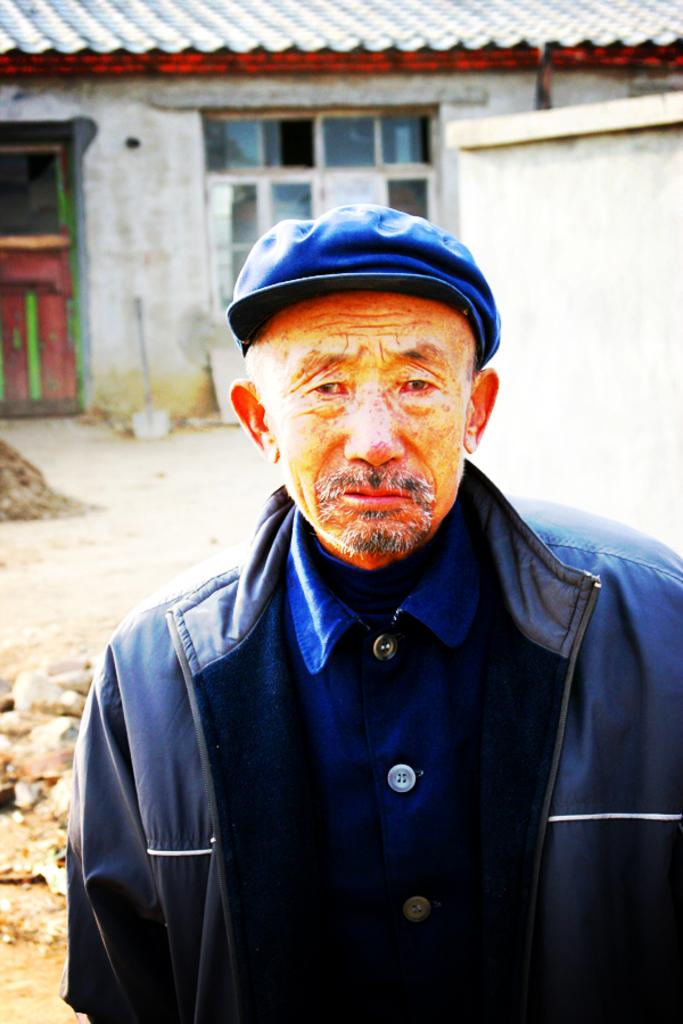Who is the main subject in the front of the image? There is a man in the front of the image. What is the man wearing on his head? The man is wearing a cap. What can be seen in the background of the image? There is a house in the background of the image. What features of the house are visible? There is a door and windows visible on the house. What is present at the bottom of the image? There are stones at the bottom of the image. How many rings can be seen on the man's fingers in the image? There are no rings visible on the man's fingers in the image. Can you tell me how the man is kicking the ball in the image? There is no ball present in the image, so the man is not kicking anything. 